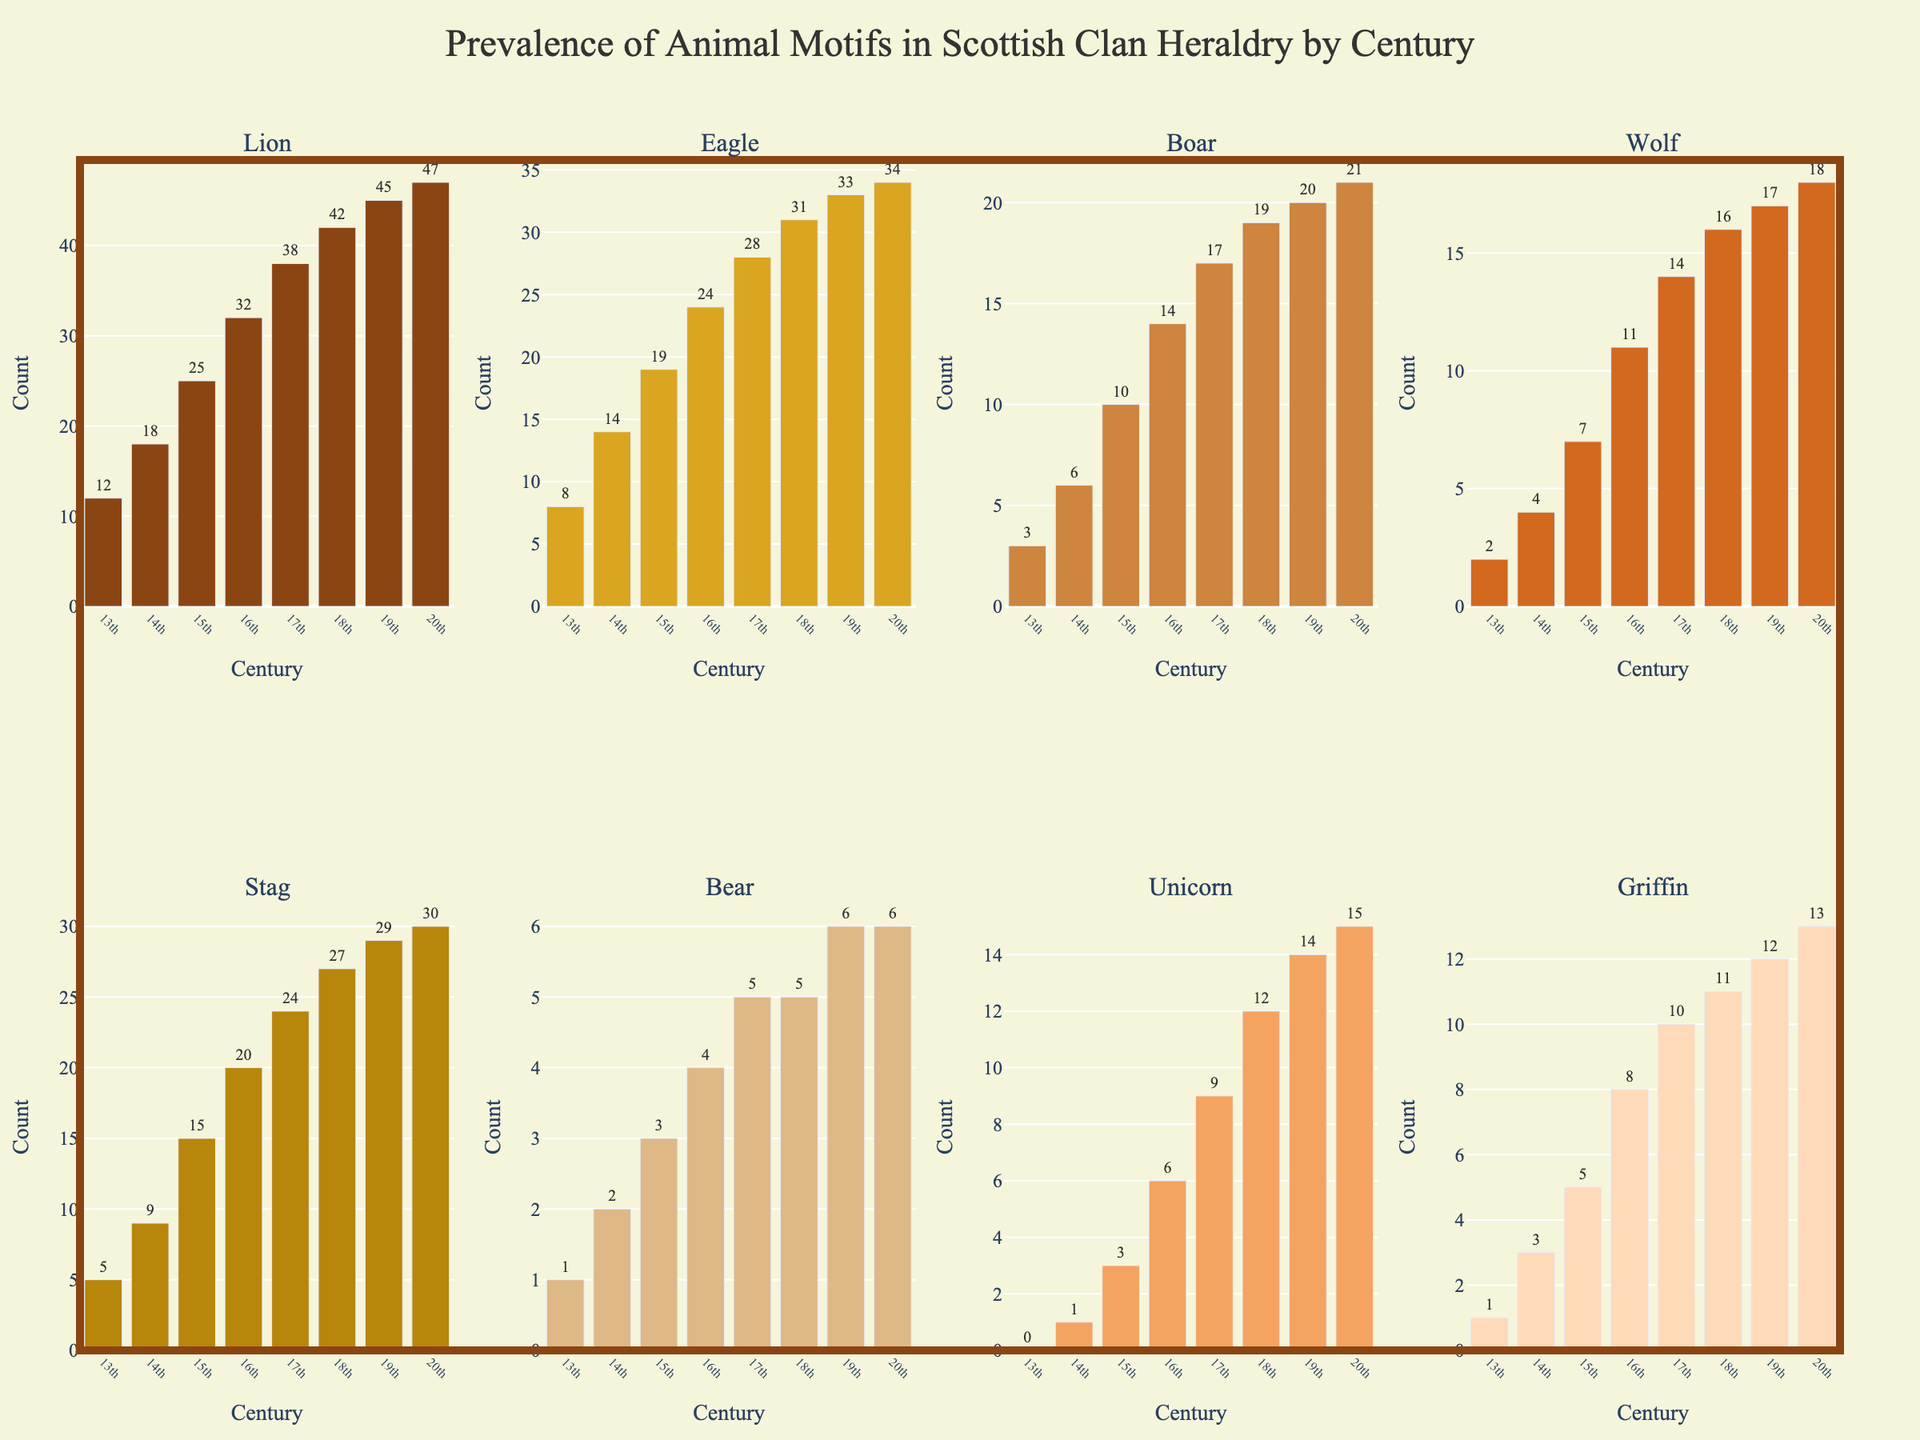What animal motif saw the greatest increase in prevalence from the 13th to the 20th century? To find the answer, compare the counts of each animal motif in the 13th century to their counts in the 20th century. The lion increased from 12 to 47 (35 increase), the eagle from 8 to 34 (26 increase), etc. The lion saw the greatest increase.
Answer: Lion Which century saw the highest prevalence of the unicorn motif? Look at the bar representing the unicorn motif in each century's subplot. The tallest bar for the unicorn is in the 20th century.
Answer: 20th century How did the prevalence of the stag motif change between the 15th and 17th centuries? Find the values for the stag motif in the 15th century (15) and the 17th century (24). Subtract the 15th century value from the 17th century value: 24 - 15 = 9.
Answer: Increase by 9 Which animal motif had the least overall prevalence in the 13th century? Look at the bars in the 13th-century subplot for the shortest bar. The bear motif has a bar with a height of 1, which is the least.
Answer: Bear During which century did the griffin motif double in prevalence from its previous century? Identify any centuries where the griffin motif's count is roughly twice the previous century's count. From the 16th to the 17th century, it increased from 8 to 10 (less than double), but from the 17th to the 18th century, it increased from 10 to 11, not quite doubling. The 18th century saw the most significant relative increase without exactly doubling.
Answer: 18th century What is the total count of the lion and eagle motifs in the 20th century combined? Add the counts for the lion (47) and eagle (34) motifs in the 20th century: 47 + 34 = 81.
Answer: 81 Which motif had a consistent increase in prevalence across all centuries? Check each motif's values from the 13th to the 20th century; the lion (12, 18, 25, 32, 38, 42, 45, 47) shows a consistent increase every century.
Answer: Lion What was the average prevalence of the boar motif in the 16th and 17th centuries? Compute the average of the boar motif counts in the 16th (14) and 17th (17) centuries: (14 + 17) / 2 = 15.5.
Answer: 15.5 Which animal motif experienced the largest decrease from the 14th to the 15th century? Compare the values from the 14th to the 15th century for each motif. All motifs either increase or maintain the same count, so there is no decrease.
Answer: None 